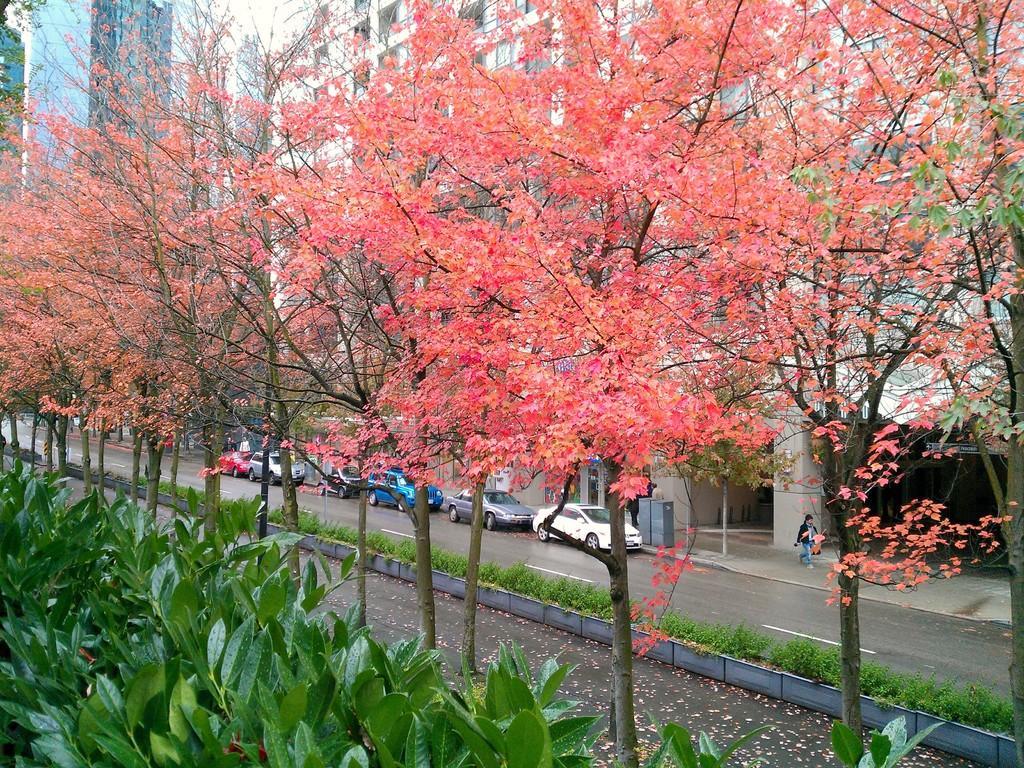Could you give a brief overview of what you see in this image? In this image we can see buildings, there are vehicles on the road, there is a person walking on the pavements, there is a pole, box, also we can see trees, plants, and some leaves on the road. 